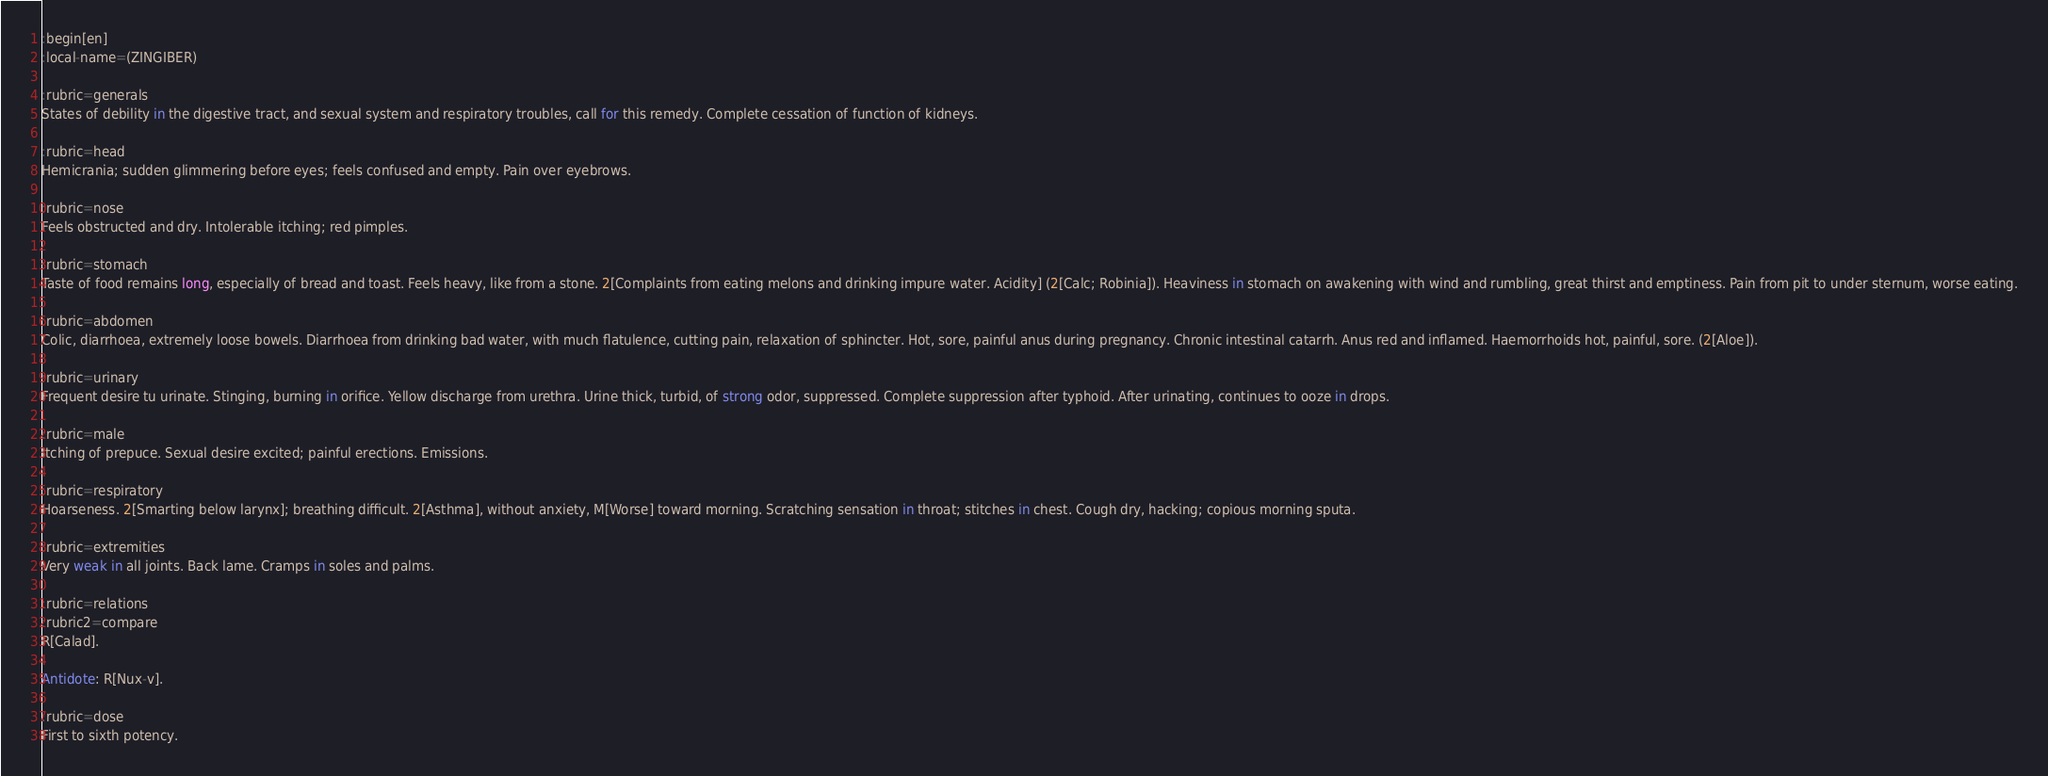Convert code to text. <code><loc_0><loc_0><loc_500><loc_500><_ObjectiveC_>:begin[en]
:local-name=(ZINGIBER)

:rubric=generals
States of debility in the digestive tract, and sexual system and respiratory troubles, call for this remedy. Complete cessation of function of kidneys.

:rubric=head
Hemicrania; sudden glimmering before eyes; feels confused and empty. Pain over eyebrows.

:rubric=nose
Feels obstructed and dry. Intolerable itching; red pimples.

:rubric=stomach
Taste of food remains long, especially of bread and toast. Feels heavy, like from a stone. 2[Complaints from eating melons and drinking impure water. Acidity] (2[Calc; Robinia]). Heaviness in stomach on awakening with wind and rumbling, great thirst and emptiness. Pain from pit to under sternum, worse eating.

:rubric=abdomen
Colic, diarrhoea, extremely loose bowels. Diarrhoea from drinking bad water, with much flatulence, cutting pain, relaxation of sphincter. Hot, sore, painful anus during pregnancy. Chronic intestinal catarrh. Anus red and inflamed. Haemorrhoids hot, painful, sore. (2[Aloe]).

:rubric=urinary
Frequent desire tu urinate. Stinging, burning in orifice. Yellow discharge from urethra. Urine thick, turbid, of strong odor, suppressed. Complete suppression after typhoid. After urinating, continues to ooze in drops.

:rubric=male
Itching of prepuce. Sexual desire excited; painful erections. Emissions.

:rubric=respiratory
Hoarseness. 2[Smarting below larynx]; breathing difficult. 2[Asthma], without anxiety, M[Worse] toward morning. Scratching sensation in throat; stitches in chest. Cough dry, hacking; copious morning sputa.

:rubric=extremities
Very weak in all joints. Back lame. Cramps in soles and palms.

:rubric=relations
:rubric2=compare
R[Calad].

Antidote: R[Nux-v].

:rubric=dose
First to sixth potency.

</code> 